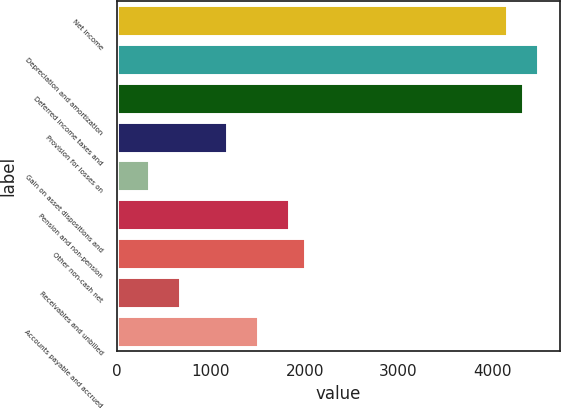Convert chart to OTSL. <chart><loc_0><loc_0><loc_500><loc_500><bar_chart><fcel>Net income<fcel>Depreciation and amortization<fcel>Deferred income taxes and<fcel>Provision for losses on<fcel>Gain on asset dispositions and<fcel>Pension and non-pension<fcel>Other non-cash net<fcel>Receivables and unbilled<fcel>Accounts payable and accrued<nl><fcel>4157.5<fcel>4488.9<fcel>4323.2<fcel>1174.9<fcel>346.4<fcel>1837.7<fcel>2003.4<fcel>677.8<fcel>1506.3<nl></chart> 